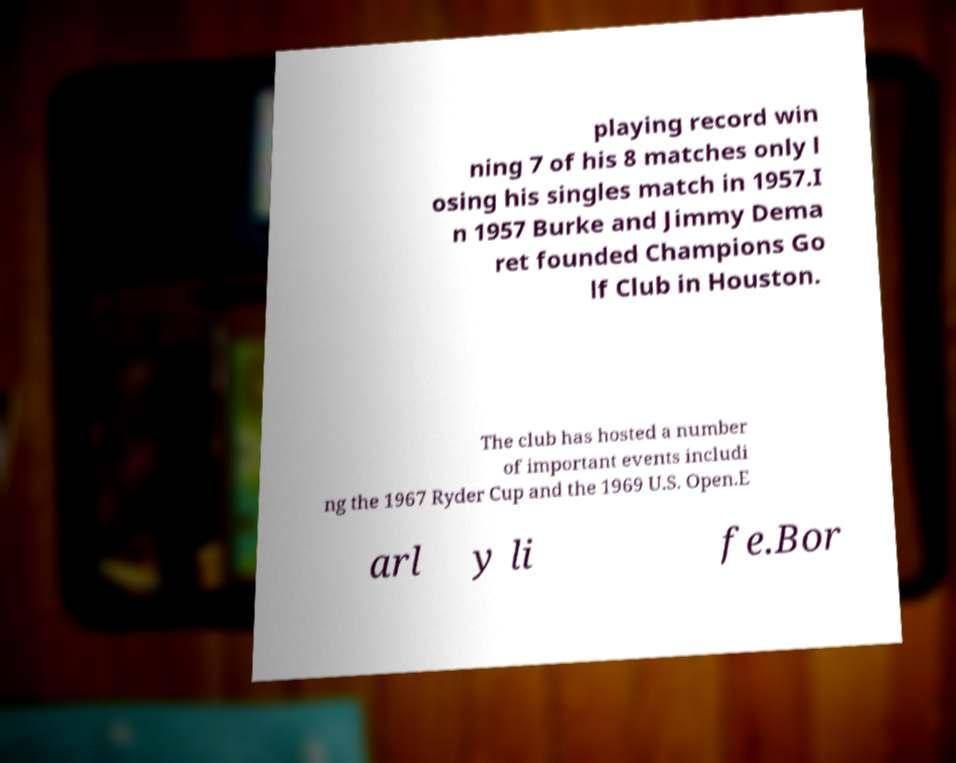Can you read and provide the text displayed in the image?This photo seems to have some interesting text. Can you extract and type it out for me? playing record win ning 7 of his 8 matches only l osing his singles match in 1957.I n 1957 Burke and Jimmy Dema ret founded Champions Go lf Club in Houston. The club has hosted a number of important events includi ng the 1967 Ryder Cup and the 1969 U.S. Open.E arl y li fe.Bor 